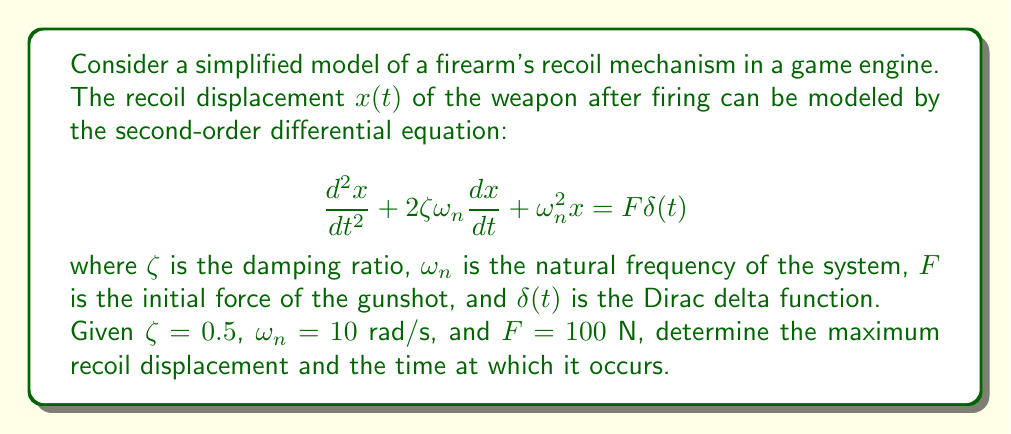Can you answer this question? To solve this problem, we need to follow these steps:

1) First, we need to find the general solution to the homogeneous equation:

   $$\frac{d^2x}{dt^2} + 2\zeta\omega_n\frac{dx}{dt} + \omega_n^2x = 0$$

2) The characteristic equation is:

   $$s^2 + 2\zeta\omega_n s + \omega_n^2 = 0$$

3) Substituting the given values:

   $$s^2 + 2(0.5)(10)s + 10^2 = 0$$
   $$s^2 + 10s + 100 = 0$$

4) Solving this quadratic equation:

   $$s = \frac{-10 \pm \sqrt{100 - 400}}{2} = -5 \pm 5i$$

5) Therefore, the general solution is:

   $$x(t) = e^{-5t}(A\cos(5t) + B\sin(5t))$$

6) To find the particular solution, we use the Laplace transform method. The Laplace transform of the equation is:

   $$s^2X(s) + 10sX(s) + 100X(s) = 100$$

7) Solving for X(s):

   $$X(s) = \frac{100}{s^2 + 10s + 100} = \frac{100}{(s+5)^2 + 25}$$

8) The inverse Laplace transform gives:

   $$x(t) = \frac{100}{5}e^{-5t}\sin(5t)$$

9) To find the maximum displacement, we differentiate x(t) and set it to zero:

   $$\frac{dx}{dt} = 20e^{-5t}(\cos(5t) - \sin(5t)) = 0$$

10) This occurs when $\tan(5t) = 1$, or when $5t = \frac{\pi}{4}$

11) Therefore, the time of maximum displacement is:

    $$t_{max} = \frac{\pi}{20} \approx 0.1571 \text{ seconds}$$

12) The maximum displacement is:

    $$x_{max} = \frac{100}{5}e^{-5(\pi/20)}\sin(\pi/4) \approx 1.3246 \text{ meters}$$
Answer: The maximum recoil displacement is approximately 1.3246 meters, occurring at approximately 0.1571 seconds after firing. 